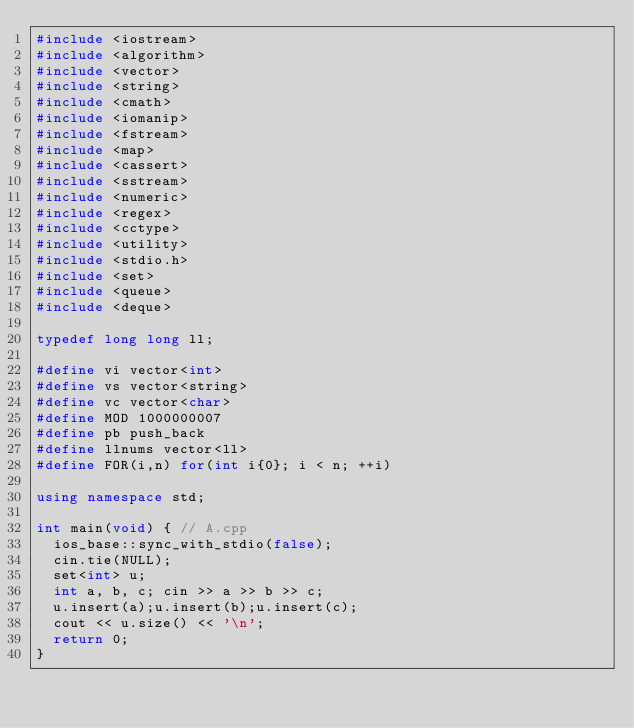<code> <loc_0><loc_0><loc_500><loc_500><_C++_>#include <iostream>
#include <algorithm>
#include <vector>
#include <string>
#include <cmath>
#include <iomanip>
#include <fstream>
#include <map>
#include <cassert>
#include <sstream>
#include <numeric>
#include <regex>
#include <cctype>
#include <utility>
#include <stdio.h>
#include <set>
#include <queue>
#include <deque>

typedef long long ll;

#define vi vector<int>
#define vs vector<string>
#define vc vector<char>
#define MOD 1000000007
#define pb push_back
#define llnums vector<ll>
#define FOR(i,n) for(int i{0}; i < n; ++i)

using namespace std;

int main(void) { // A.cpp
  ios_base::sync_with_stdio(false);
  cin.tie(NULL);
  set<int> u;
  int a, b, c; cin >> a >> b >> c;
  u.insert(a);u.insert(b);u.insert(c);
  cout << u.size() << '\n';
  return 0;
}







</code> 